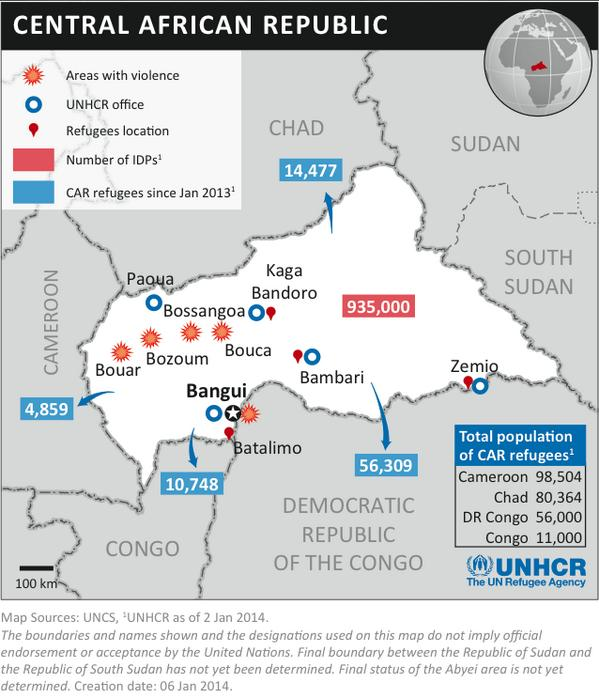Indicate a few pertinent items in this graphic. The United Nations High Commissioner for Refugees has identified 5 offices in Central African Republic. Approximately 109,504 CAR refugees currently reside in the Congo and Cameroon, according to the most recent available data. There are 91,364 CAR refugees in Congo and Chad. As of January 2013, there have been approximately 935,000 IDPs in Central African Republic. The infographics depict a mapping of five areas in relation to violence. 